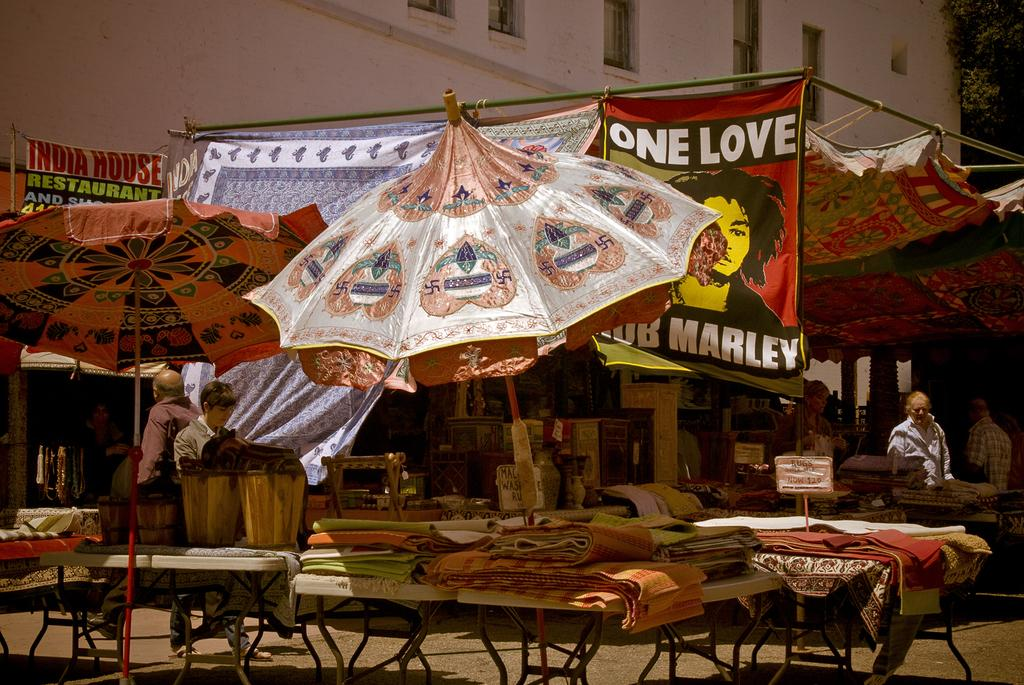What is the main object in the image? There is a table in the image. What is being sold at the table? Mats are being sold at the table. Can you describe the cloth in the image? There is a cloth with a picture of a person and text in the image. What can be seen in the background of the image? There is a building in the background of the image. What additional object is present in the image? There is an umbrella in the image. What is the man in the image doing? A man is walking in the image. What type of hook is the man using to catch fish in the image? There is no hook or fishing activity present in the image; the man is simply walking. 